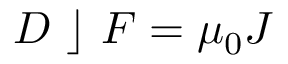Convert formula to latex. <formula><loc_0><loc_0><loc_500><loc_500>D \rfloor F = \mu _ { 0 } J</formula> 